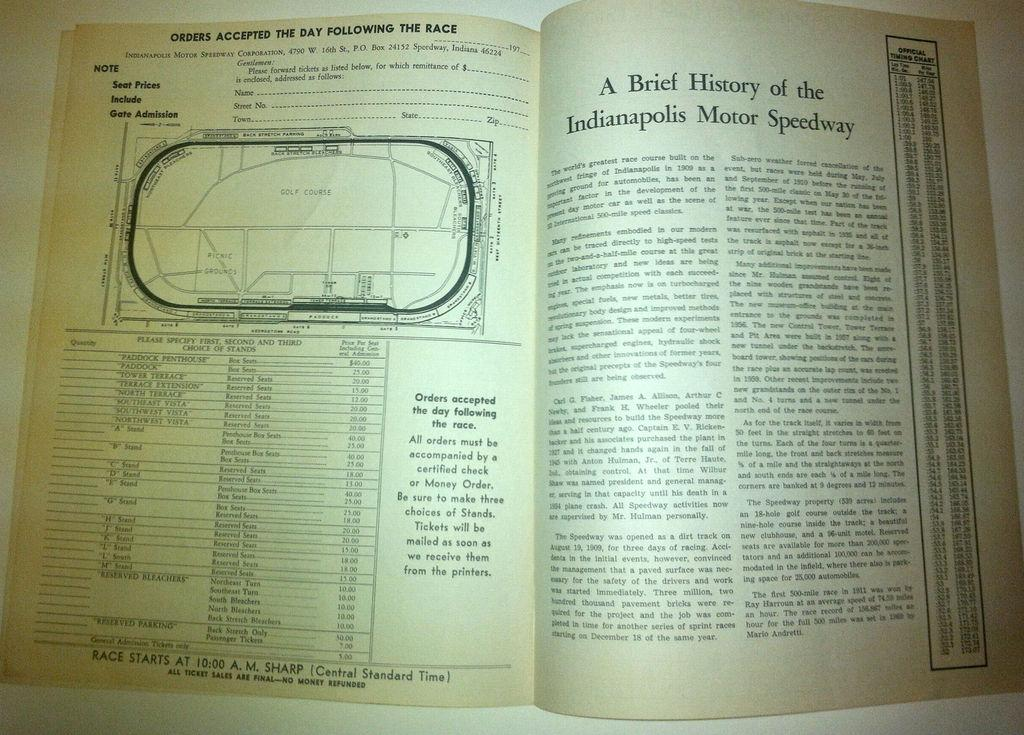<image>
Relay a brief, clear account of the picture shown. An open book with the title A Brief History of the Indianapolis Motor Speedway. 